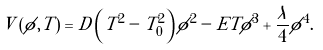<formula> <loc_0><loc_0><loc_500><loc_500>V \left ( \phi , T \right ) = D \left ( T ^ { 2 } - T _ { 0 } ^ { 2 } \right ) \phi ^ { 2 } - E T \phi ^ { 3 } + \frac { \lambda } { 4 } \phi ^ { 4 } .</formula> 